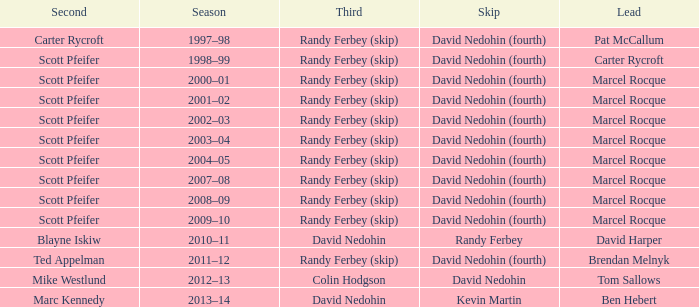Which Third has a Second of scott pfeifer? Randy Ferbey (skip), Randy Ferbey (skip), Randy Ferbey (skip), Randy Ferbey (skip), Randy Ferbey (skip), Randy Ferbey (skip), Randy Ferbey (skip), Randy Ferbey (skip), Randy Ferbey (skip). Help me parse the entirety of this table. {'header': ['Second', 'Season', 'Third', 'Skip', 'Lead'], 'rows': [['Carter Rycroft', '1997–98', 'Randy Ferbey (skip)', 'David Nedohin (fourth)', 'Pat McCallum'], ['Scott Pfeifer', '1998–99', 'Randy Ferbey (skip)', 'David Nedohin (fourth)', 'Carter Rycroft'], ['Scott Pfeifer', '2000–01', 'Randy Ferbey (skip)', 'David Nedohin (fourth)', 'Marcel Rocque'], ['Scott Pfeifer', '2001–02', 'Randy Ferbey (skip)', 'David Nedohin (fourth)', 'Marcel Rocque'], ['Scott Pfeifer', '2002–03', 'Randy Ferbey (skip)', 'David Nedohin (fourth)', 'Marcel Rocque'], ['Scott Pfeifer', '2003–04', 'Randy Ferbey (skip)', 'David Nedohin (fourth)', 'Marcel Rocque'], ['Scott Pfeifer', '2004–05', 'Randy Ferbey (skip)', 'David Nedohin (fourth)', 'Marcel Rocque'], ['Scott Pfeifer', '2007–08', 'Randy Ferbey (skip)', 'David Nedohin (fourth)', 'Marcel Rocque'], ['Scott Pfeifer', '2008–09', 'Randy Ferbey (skip)', 'David Nedohin (fourth)', 'Marcel Rocque'], ['Scott Pfeifer', '2009–10', 'Randy Ferbey (skip)', 'David Nedohin (fourth)', 'Marcel Rocque'], ['Blayne Iskiw', '2010–11', 'David Nedohin', 'Randy Ferbey', 'David Harper'], ['Ted Appelman', '2011–12', 'Randy Ferbey (skip)', 'David Nedohin (fourth)', 'Brendan Melnyk'], ['Mike Westlund', '2012–13', 'Colin Hodgson', 'David Nedohin', 'Tom Sallows'], ['Marc Kennedy', '2013–14', 'David Nedohin', 'Kevin Martin', 'Ben Hebert']]} 